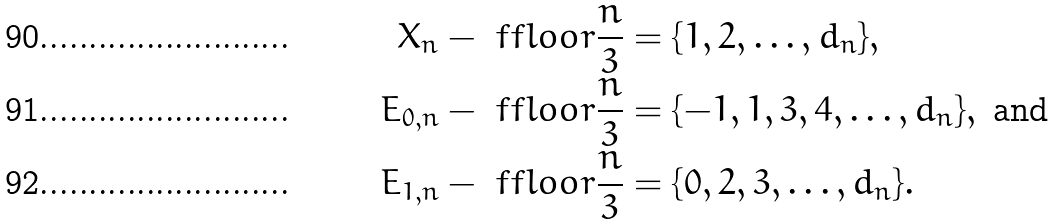<formula> <loc_0><loc_0><loc_500><loc_500>X _ { n } - \ f f l o o r { \frac { n } { 3 } } & = \{ 1 , 2 , \dots , d _ { n } \} , \\ E _ { 0 , n } - \ f f l o o r { \frac { n } { 3 } } & = \{ - 1 , 1 , 3 , 4 , \dots , d _ { n } \} , \text { and} \\ E _ { 1 , n } - \ f f l o o r { \frac { n } { 3 } } & = \{ 0 , 2 , 3 , \dots , d _ { n } \} .</formula> 